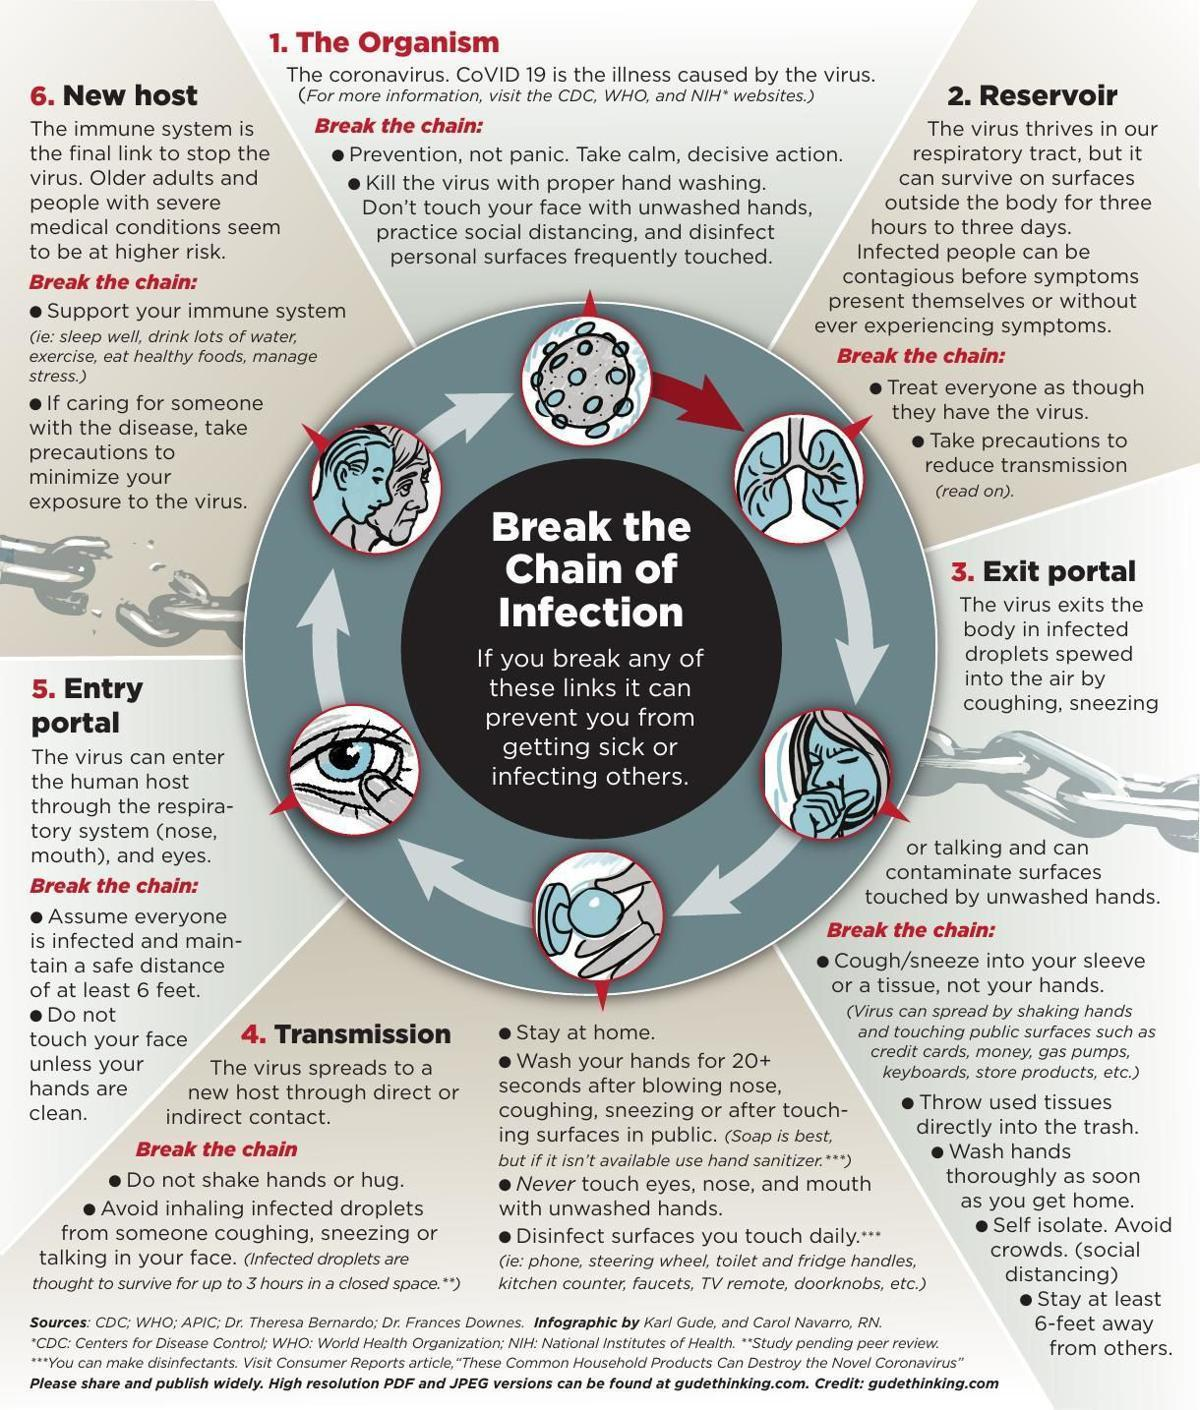What is the second topic given in this infographic?
Answer the question with a short phrase. reservoir What is the fourth topic given in this infographic? transmission what is the second bulletin point given under the second subtopic? take precautions to reduce transmission what is the point given just below "break the chain:" under the first subtopic? prevention, not panic. take calm, decisive action. what is the third bulletin point given under the fourth subtopic? stay at home what is the second last bulletin point given under the  third subtopic? self isolate. avoid crowds. (social distancing) What is the third topic given in this infographic? exit portal What is the fifth topic given in this infographic? entry portal what is the second bulletin point given under the fifth subtopic? do not touch your face unless your hands are clean 